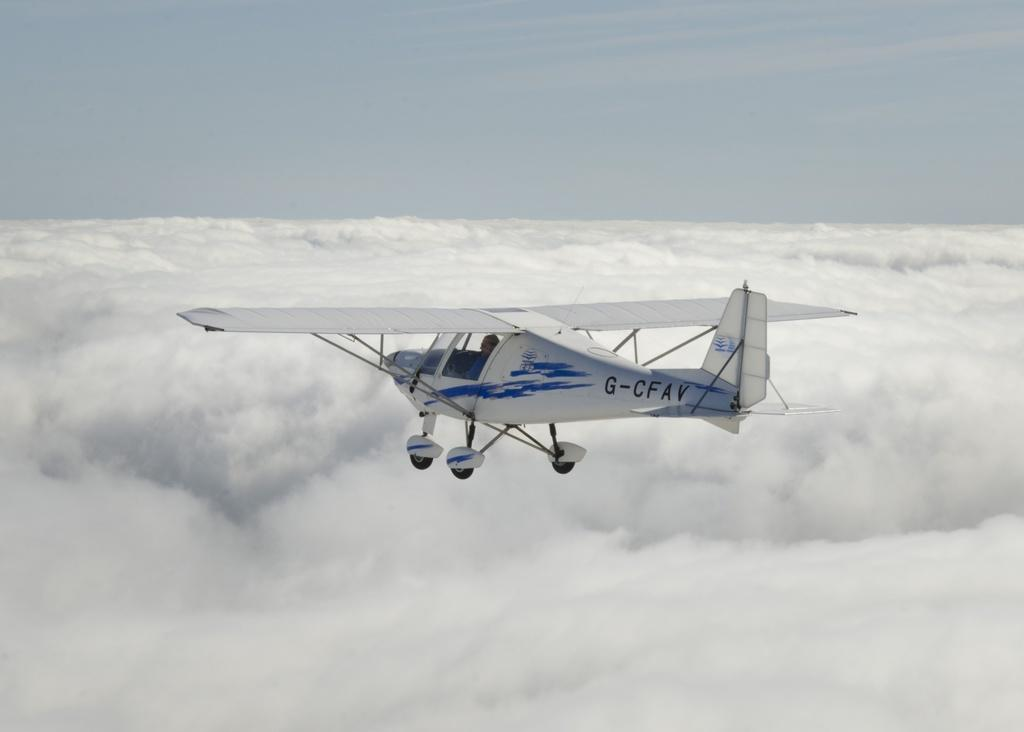What is the main subject of the picture? The main subject of the picture is an airplane. What is the color of the airplane? The airplane is white in color. What is the airplane doing in the image? The airplane is flying in the air. Can you describe the airplane's position relative to the clouds? The airplane is flying above the clouds. What can be seen in the background of the image? There is a sky visible in the background of the image, and clouds are present. What type of fruit can be seen hanging from the airplane's wing in the image? There is no fruit hanging from the airplane's wing in the image. Can you smell the bees in the image? There are no bees present in the image, so it is not possible to smell them. 